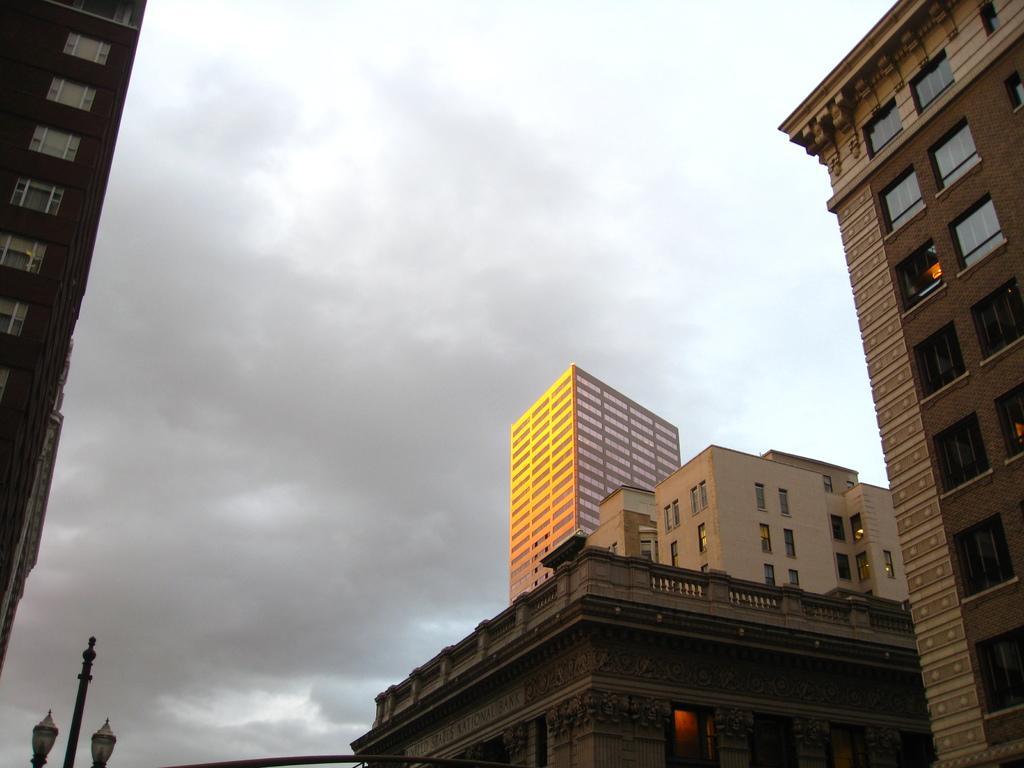Could you give a brief overview of what you see in this image? In this image I can see few buildings, windows, light poles and the sky. 